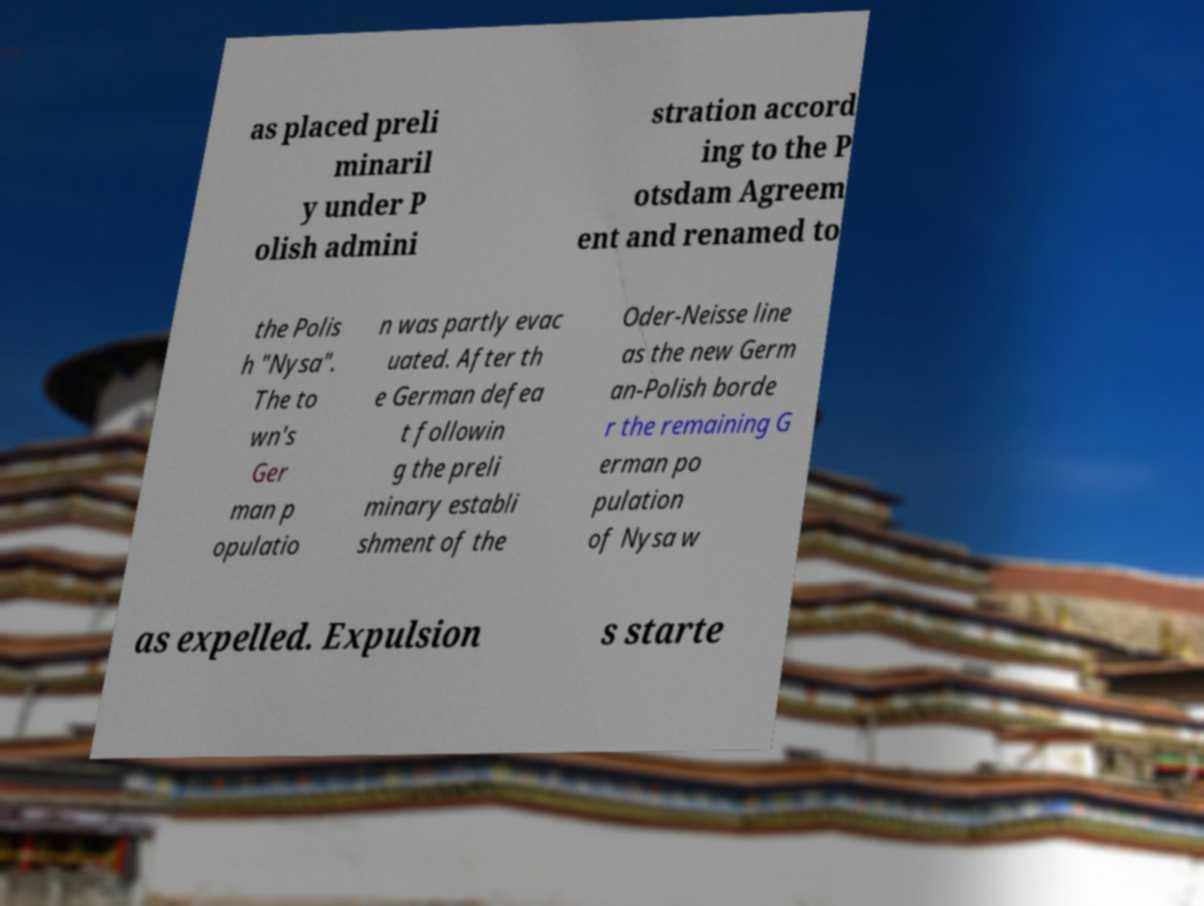Please identify and transcribe the text found in this image. as placed preli minaril y under P olish admini stration accord ing to the P otsdam Agreem ent and renamed to the Polis h "Nysa". The to wn's Ger man p opulatio n was partly evac uated. After th e German defea t followin g the preli minary establi shment of the Oder-Neisse line as the new Germ an-Polish borde r the remaining G erman po pulation of Nysa w as expelled. Expulsion s starte 